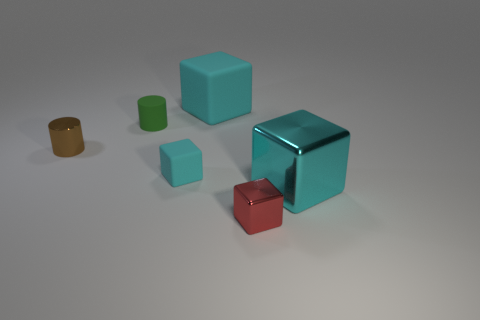Subtract all yellow spheres. How many cyan blocks are left? 3 Add 4 red shiny cubes. How many objects exist? 10 Subtract all cylinders. How many objects are left? 4 Subtract 0 brown balls. How many objects are left? 6 Subtract all large purple metal spheres. Subtract all cyan things. How many objects are left? 3 Add 2 big blocks. How many big blocks are left? 4 Add 4 tiny green matte objects. How many tiny green matte objects exist? 5 